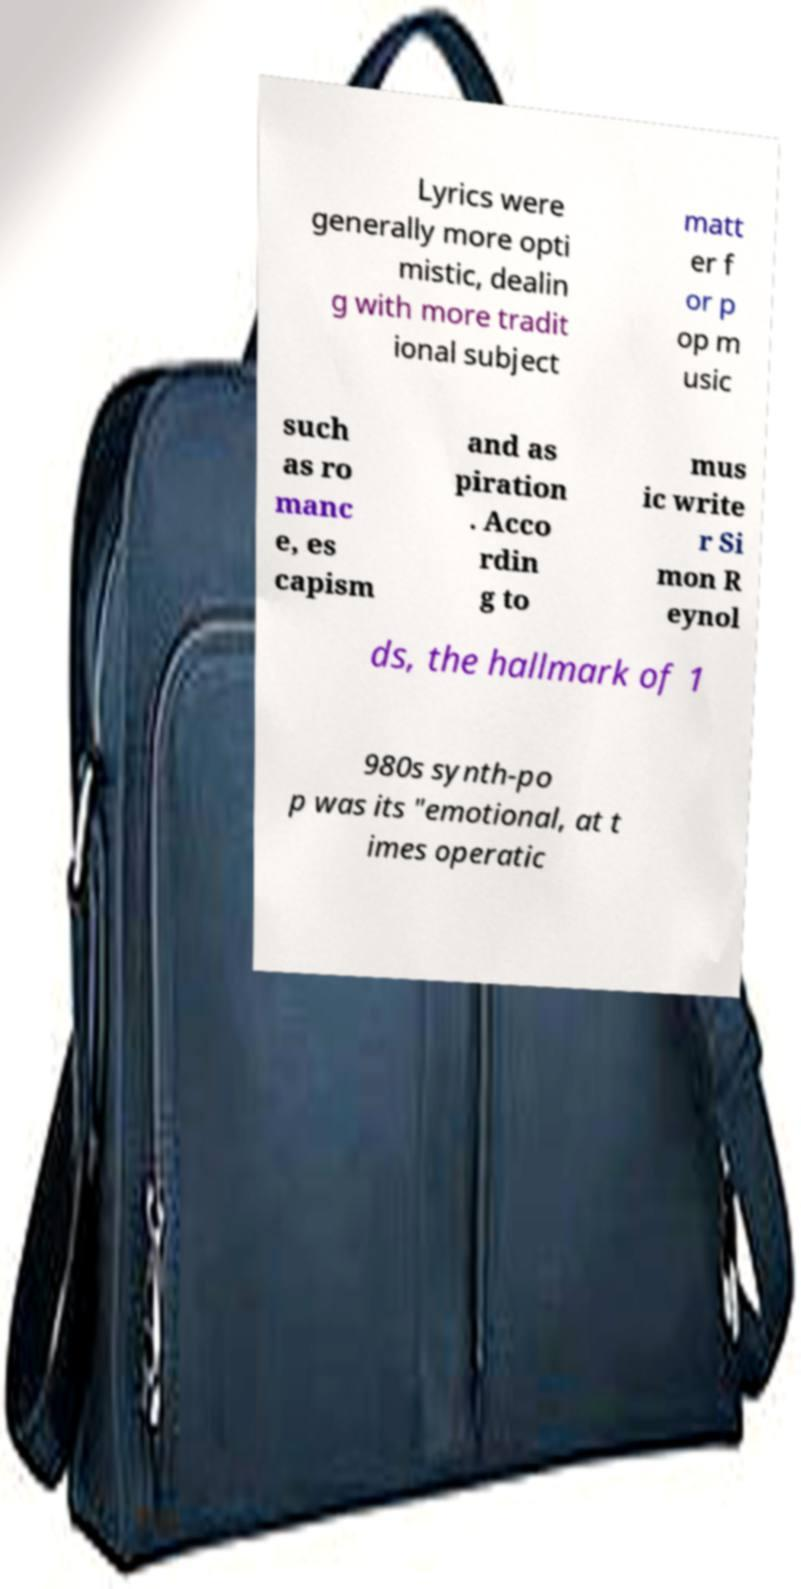There's text embedded in this image that I need extracted. Can you transcribe it verbatim? Lyrics were generally more opti mistic, dealin g with more tradit ional subject matt er f or p op m usic such as ro manc e, es capism and as piration . Acco rdin g to mus ic write r Si mon R eynol ds, the hallmark of 1 980s synth-po p was its "emotional, at t imes operatic 